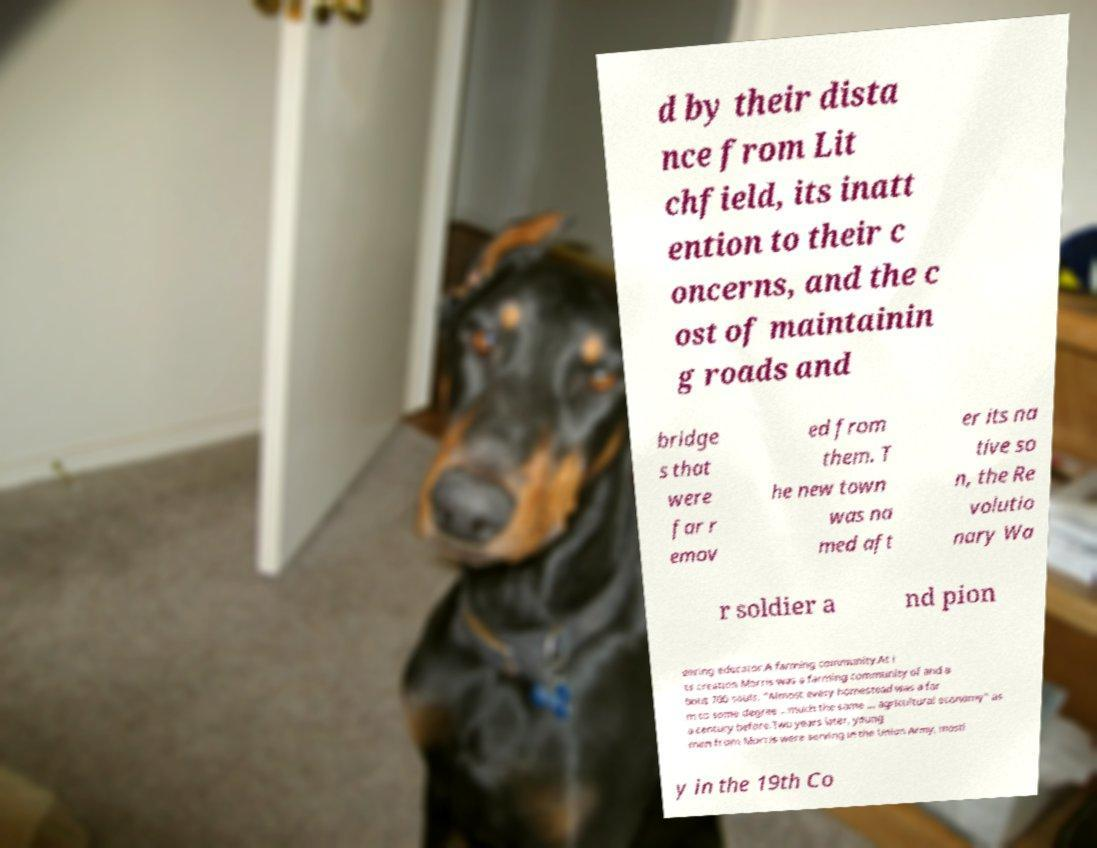Can you read and provide the text displayed in the image?This photo seems to have some interesting text. Can you extract and type it out for me? d by their dista nce from Lit chfield, its inatt ention to their c oncerns, and the c ost of maintainin g roads and bridge s that were far r emov ed from them. T he new town was na med aft er its na tive so n, the Re volutio nary Wa r soldier a nd pion eering educator.A farming community.At i ts creation Morris was a farming community of and a bout 700 souls. "Almost every homestead was a far m to some degree …much the same … agricultural economy" as a century before.Two years later, young men from Morris were serving in the Union Army, mostl y in the 19th Co 